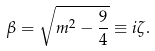Convert formula to latex. <formula><loc_0><loc_0><loc_500><loc_500>\beta = \sqrt { m ^ { 2 } - \frac { 9 } { 4 } } \equiv i \zeta .</formula> 